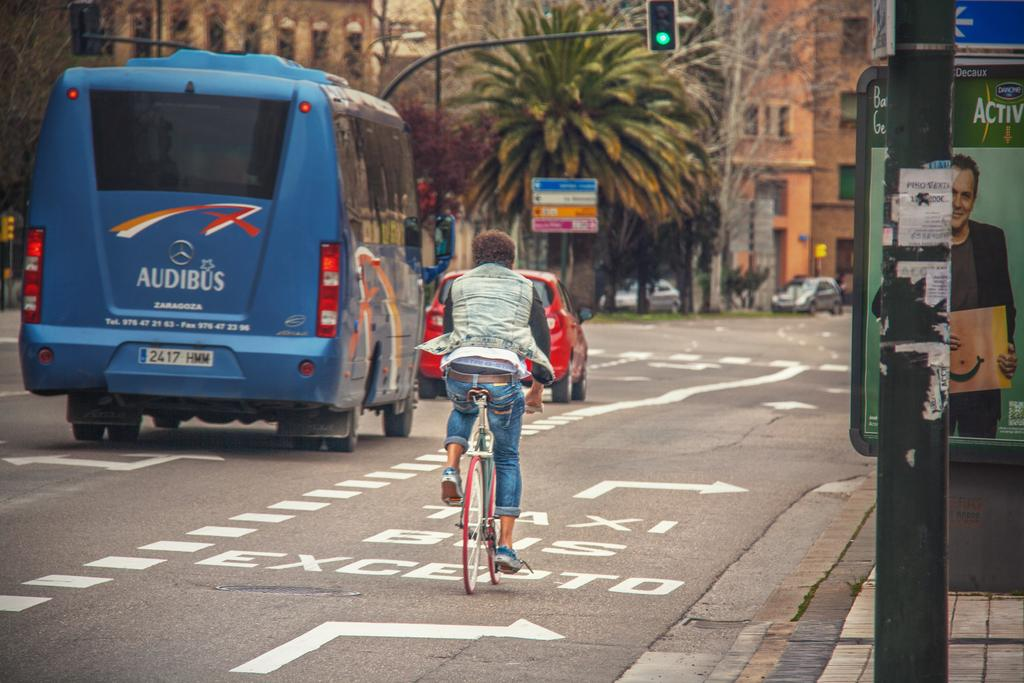What is the person in the image doing? The person in the image is riding a bicycle. What other mode of transportation can be seen in the image? There is a bus in the image. What can be seen in the background of the image? There are buildings and trees in the background of the image. How many oranges are hanging from the trees in the image? There are no oranges present in the image; only trees can be seen in the background. 